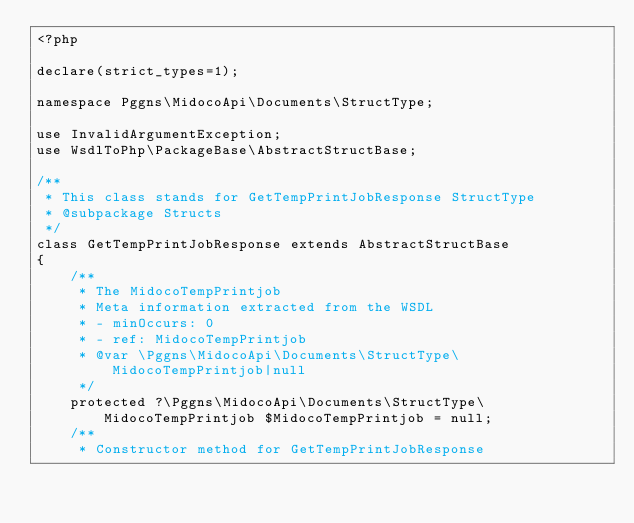<code> <loc_0><loc_0><loc_500><loc_500><_PHP_><?php

declare(strict_types=1);

namespace Pggns\MidocoApi\Documents\StructType;

use InvalidArgumentException;
use WsdlToPhp\PackageBase\AbstractStructBase;

/**
 * This class stands for GetTempPrintJobResponse StructType
 * @subpackage Structs
 */
class GetTempPrintJobResponse extends AbstractStructBase
{
    /**
     * The MidocoTempPrintjob
     * Meta information extracted from the WSDL
     * - minOccurs: 0
     * - ref: MidocoTempPrintjob
     * @var \Pggns\MidocoApi\Documents\StructType\MidocoTempPrintjob|null
     */
    protected ?\Pggns\MidocoApi\Documents\StructType\MidocoTempPrintjob $MidocoTempPrintjob = null;
    /**
     * Constructor method for GetTempPrintJobResponse</code> 